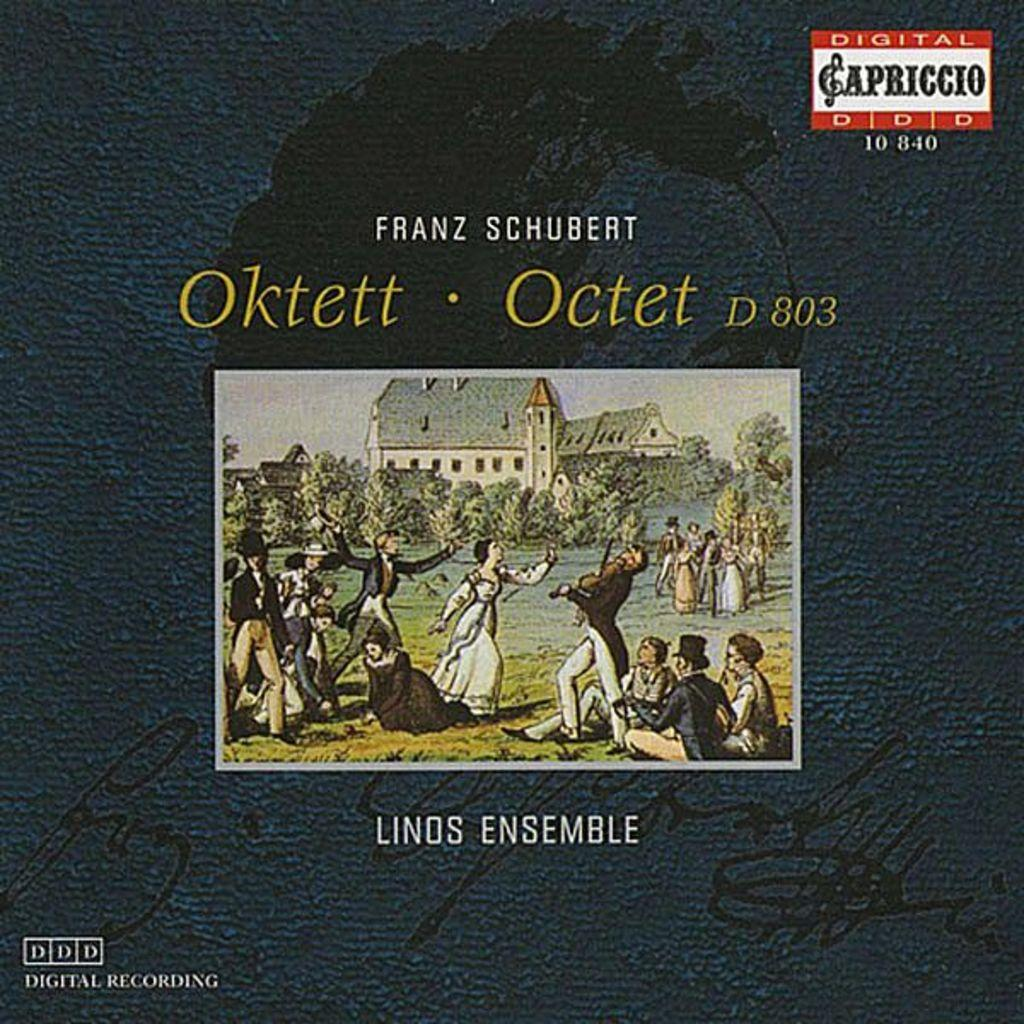<image>
Describe the image concisely. a record cover that says 'franz schubert' on it 